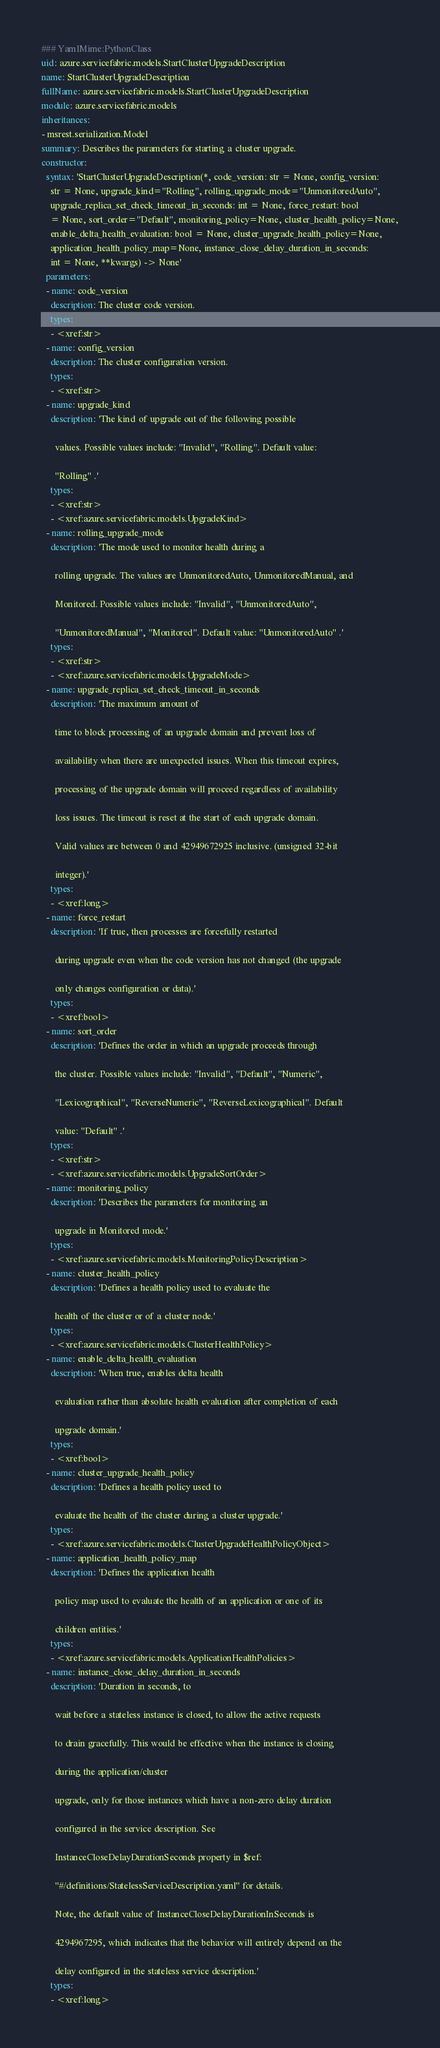Convert code to text. <code><loc_0><loc_0><loc_500><loc_500><_YAML_>### YamlMime:PythonClass
uid: azure.servicefabric.models.StartClusterUpgradeDescription
name: StartClusterUpgradeDescription
fullName: azure.servicefabric.models.StartClusterUpgradeDescription
module: azure.servicefabric.models
inheritances:
- msrest.serialization.Model
summary: Describes the parameters for starting a cluster upgrade.
constructor:
  syntax: 'StartClusterUpgradeDescription(*, code_version: str = None, config_version:
    str = None, upgrade_kind=''Rolling'', rolling_upgrade_mode=''UnmonitoredAuto'',
    upgrade_replica_set_check_timeout_in_seconds: int = None, force_restart: bool
    = None, sort_order=''Default'', monitoring_policy=None, cluster_health_policy=None,
    enable_delta_health_evaluation: bool = None, cluster_upgrade_health_policy=None,
    application_health_policy_map=None, instance_close_delay_duration_in_seconds:
    int = None, **kwargs) -> None'
  parameters:
  - name: code_version
    description: The cluster code version.
    types:
    - <xref:str>
  - name: config_version
    description: The cluster configuration version.
    types:
    - <xref:str>
  - name: upgrade_kind
    description: 'The kind of upgrade out of the following possible

      values. Possible values include: ''Invalid'', ''Rolling''. Default value:

      "Rolling" .'
    types:
    - <xref:str>
    - <xref:azure.servicefabric.models.UpgradeKind>
  - name: rolling_upgrade_mode
    description: 'The mode used to monitor health during a

      rolling upgrade. The values are UnmonitoredAuto, UnmonitoredManual, and

      Monitored. Possible values include: ''Invalid'', ''UnmonitoredAuto'',

      ''UnmonitoredManual'', ''Monitored''. Default value: "UnmonitoredAuto" .'
    types:
    - <xref:str>
    - <xref:azure.servicefabric.models.UpgradeMode>
  - name: upgrade_replica_set_check_timeout_in_seconds
    description: 'The maximum amount of

      time to block processing of an upgrade domain and prevent loss of

      availability when there are unexpected issues. When this timeout expires,

      processing of the upgrade domain will proceed regardless of availability

      loss issues. The timeout is reset at the start of each upgrade domain.

      Valid values are between 0 and 42949672925 inclusive. (unsigned 32-bit

      integer).'
    types:
    - <xref:long>
  - name: force_restart
    description: 'If true, then processes are forcefully restarted

      during upgrade even when the code version has not changed (the upgrade

      only changes configuration or data).'
    types:
    - <xref:bool>
  - name: sort_order
    description: 'Defines the order in which an upgrade proceeds through

      the cluster. Possible values include: ''Invalid'', ''Default'', ''Numeric'',

      ''Lexicographical'', ''ReverseNumeric'', ''ReverseLexicographical''. Default

      value: "Default" .'
    types:
    - <xref:str>
    - <xref:azure.servicefabric.models.UpgradeSortOrder>
  - name: monitoring_policy
    description: 'Describes the parameters for monitoring an

      upgrade in Monitored mode.'
    types:
    - <xref:azure.servicefabric.models.MonitoringPolicyDescription>
  - name: cluster_health_policy
    description: 'Defines a health policy used to evaluate the

      health of the cluster or of a cluster node.'
    types:
    - <xref:azure.servicefabric.models.ClusterHealthPolicy>
  - name: enable_delta_health_evaluation
    description: 'When true, enables delta health

      evaluation rather than absolute health evaluation after completion of each

      upgrade domain.'
    types:
    - <xref:bool>
  - name: cluster_upgrade_health_policy
    description: 'Defines a health policy used to

      evaluate the health of the cluster during a cluster upgrade.'
    types:
    - <xref:azure.servicefabric.models.ClusterUpgradeHealthPolicyObject>
  - name: application_health_policy_map
    description: 'Defines the application health

      policy map used to evaluate the health of an application or one of its

      children entities.'
    types:
    - <xref:azure.servicefabric.models.ApplicationHealthPolicies>
  - name: instance_close_delay_duration_in_seconds
    description: 'Duration in seconds, to

      wait before a stateless instance is closed, to allow the active requests

      to drain gracefully. This would be effective when the instance is closing

      during the application/cluster

      upgrade, only for those instances which have a non-zero delay duration

      configured in the service description. See

      InstanceCloseDelayDurationSeconds property in $ref:

      "#/definitions/StatelessServiceDescription.yaml" for details.

      Note, the default value of InstanceCloseDelayDurationInSeconds is

      4294967295, which indicates that the behavior will entirely depend on the

      delay configured in the stateless service description.'
    types:
    - <xref:long>
</code> 